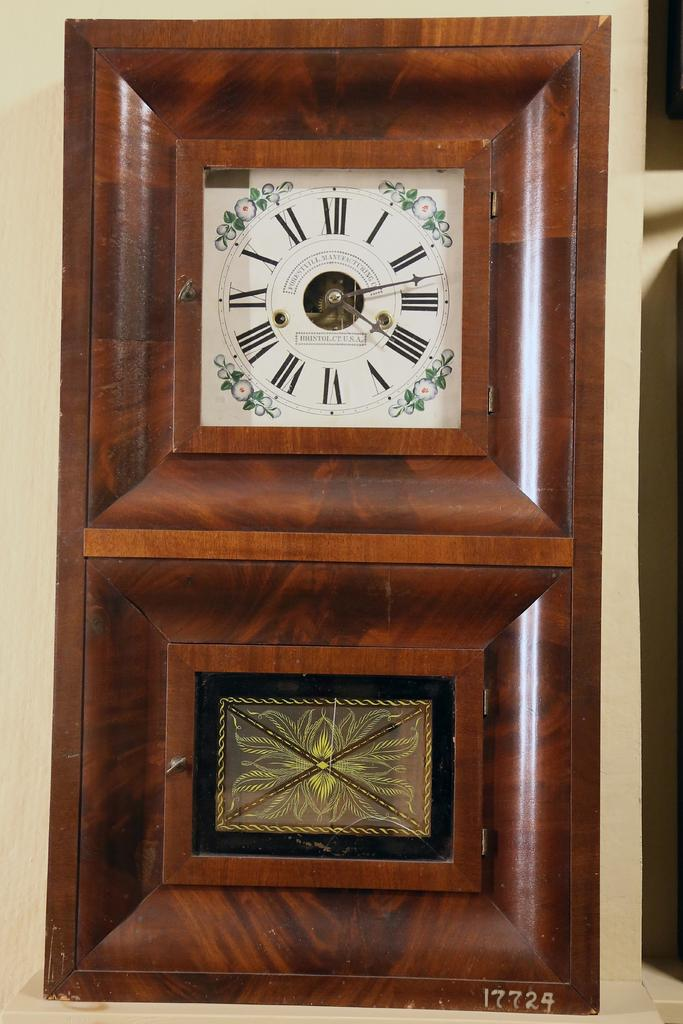<image>
Present a compact description of the photo's key features. An expensive woodworked clock with Roman numerals labeled Forestvill Manufacturing, Bristol Ct, USA 